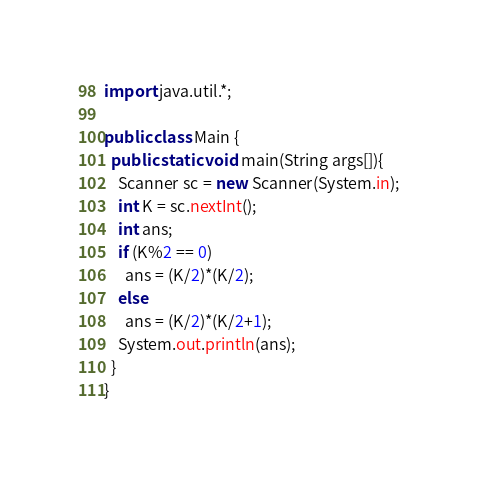<code> <loc_0><loc_0><loc_500><loc_500><_Java_>import java.util.*;
 
public class Main {
  public static void main(String args[]){
    Scanner sc = new Scanner(System.in);
    int K = sc.nextInt();
    int ans;
    if (K%2 == 0)
      ans = (K/2)*(K/2);
    else
      ans = (K/2)*(K/2+1);
    System.out.println(ans);
  }
}  </code> 